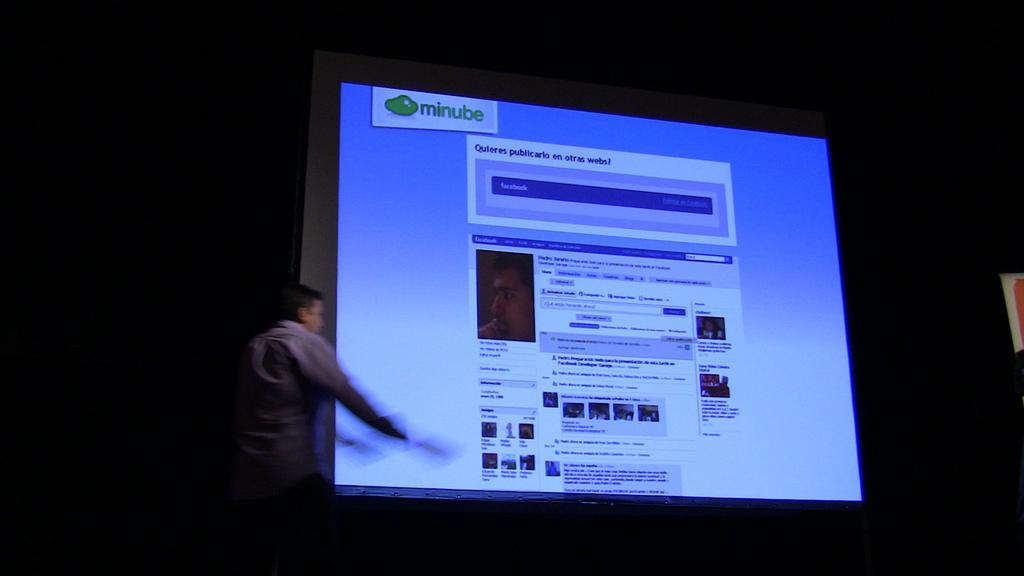<image>
Present a compact description of the photo's key features. A man is giving a presentation in front of a screen that says minube. 